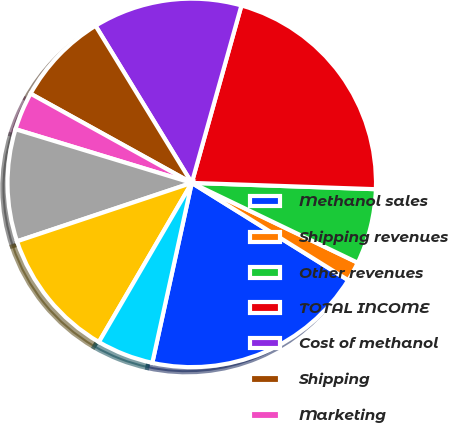Convert chart to OTSL. <chart><loc_0><loc_0><loc_500><loc_500><pie_chart><fcel>Methanol sales<fcel>Shipping revenues<fcel>Other revenues<fcel>TOTAL INCOME<fcel>Cost of methanol<fcel>Shipping<fcel>Marketing<fcel>Depreciation<fcel>General and administrative<fcel>Net profit interest<nl><fcel>19.58%<fcel>1.72%<fcel>6.59%<fcel>21.2%<fcel>13.09%<fcel>8.21%<fcel>3.34%<fcel>9.84%<fcel>11.46%<fcel>4.97%<nl></chart> 